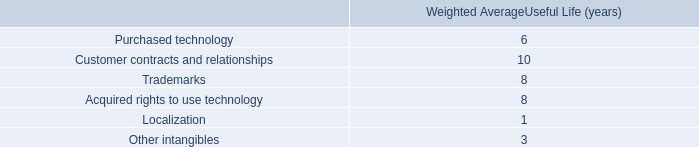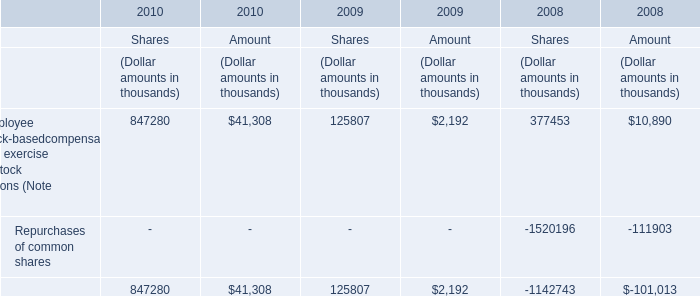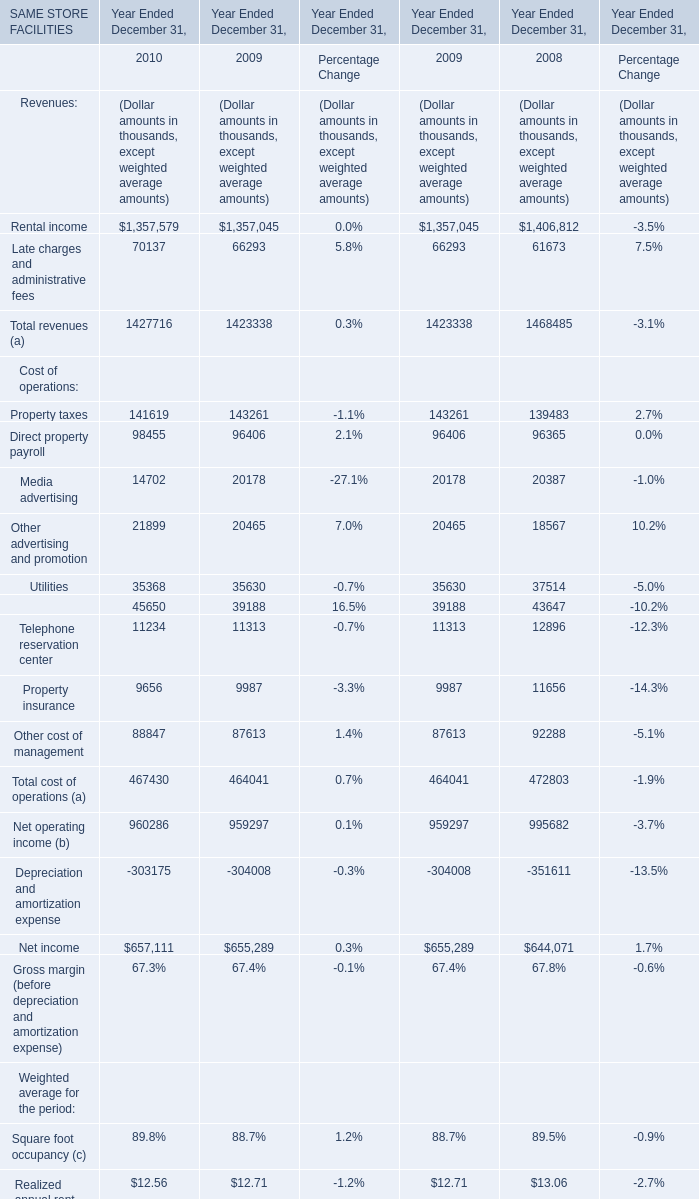what is the average weighted average useful life ( years ) for trademarks and acquired rights to use technology? 
Computations: ((8 + 8) / 2)
Answer: 8.0. When is Total cost of operations (a) the largest? 
Answer: 2008. What's the greatest value of Cost of operations in 2009? 
Answer: Property taxes. 